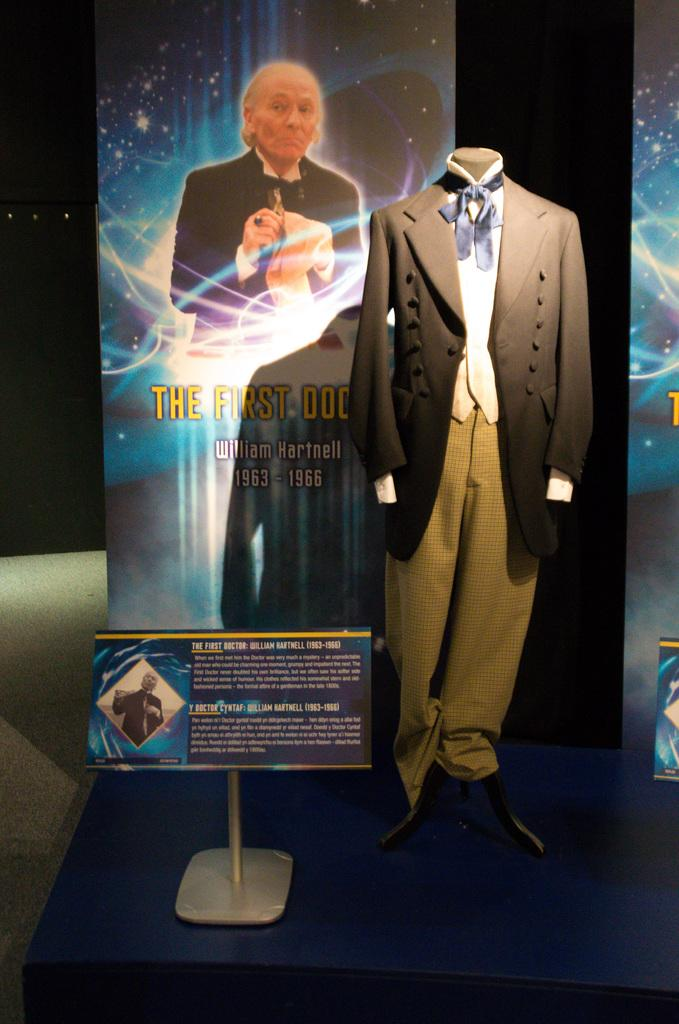What can be seen in the image related to clothing? There are clothes in the image. What object is present in the image that might be used to display clothing? There is a mannequin in the image. What is in front of the mannequin? There is a board in front of the mannequin. What can be seen in the background of the image? There are hoardings in the background of the image. How does the spy use the fan to communicate with the ocean in the image? There is no spy, fan, or ocean present in the image. 